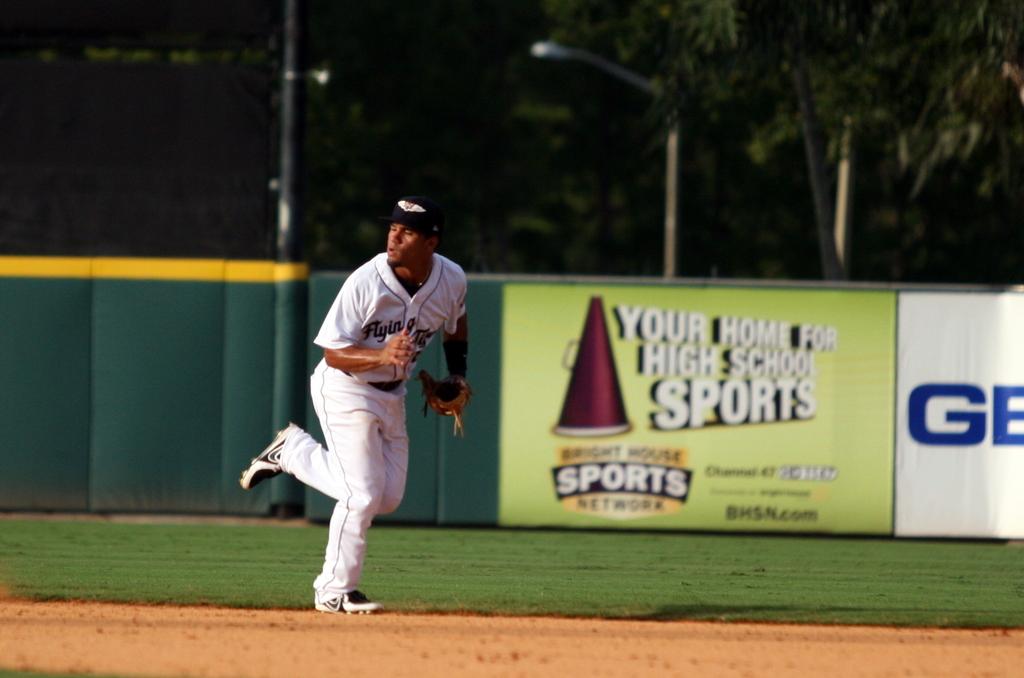What is the first letter in blue on the right?
Provide a short and direct response. G. 